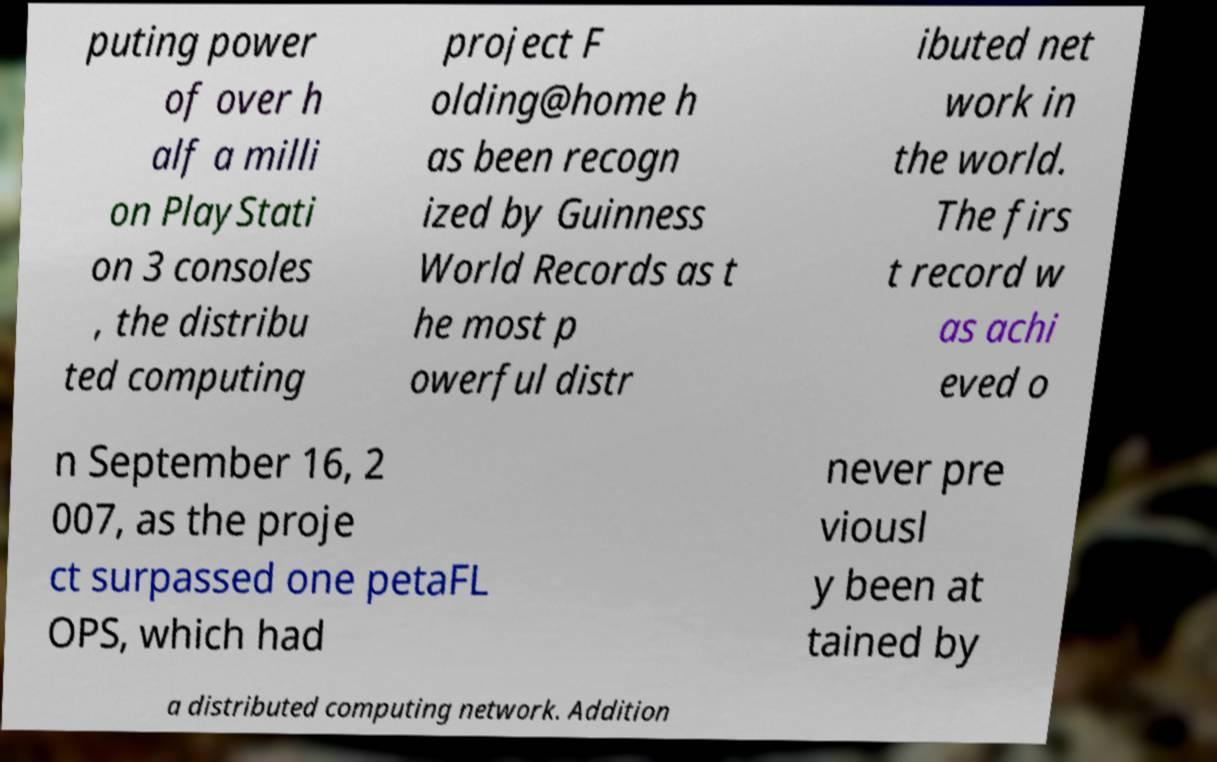Could you extract and type out the text from this image? puting power of over h alf a milli on PlayStati on 3 consoles , the distribu ted computing project F olding@home h as been recogn ized by Guinness World Records as t he most p owerful distr ibuted net work in the world. The firs t record w as achi eved o n September 16, 2 007, as the proje ct surpassed one petaFL OPS, which had never pre viousl y been at tained by a distributed computing network. Addition 